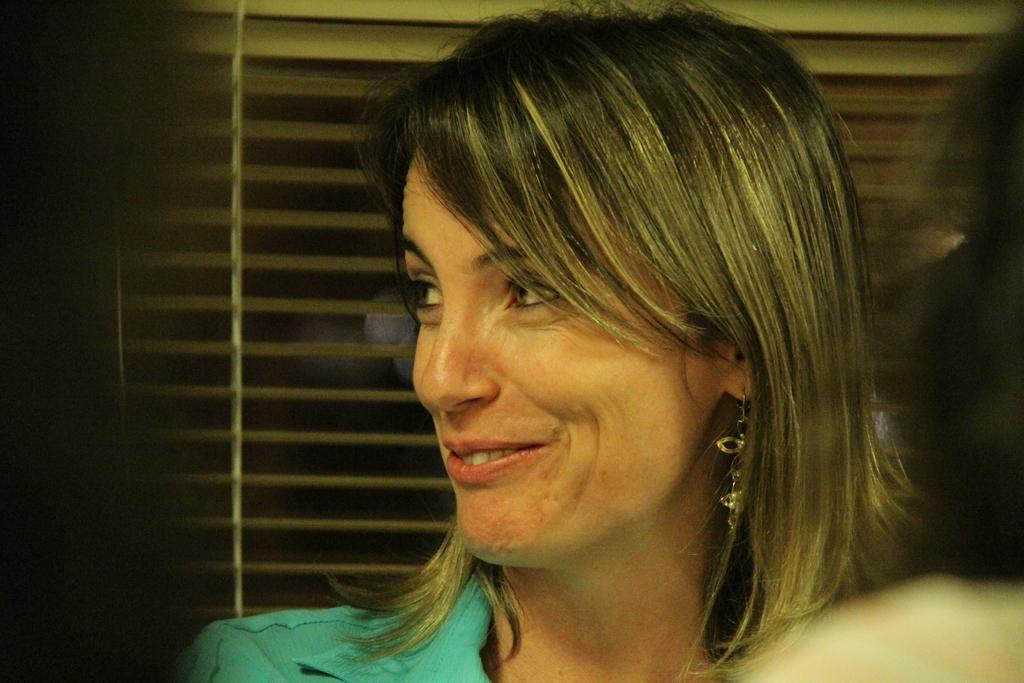Who is present in the image? There is a woman in the image. What is the woman doing in the image? The woman is smiling in the image. What is the woman wearing in the image? The woman is wearing a green dress in the image. What can be seen behind the woman in the image? There is a window behind the woman in the image. What type of lunchroom is visible in the image? There is no lunchroom present in the image. Who is the maid in the image? There is no maid present in the image. 